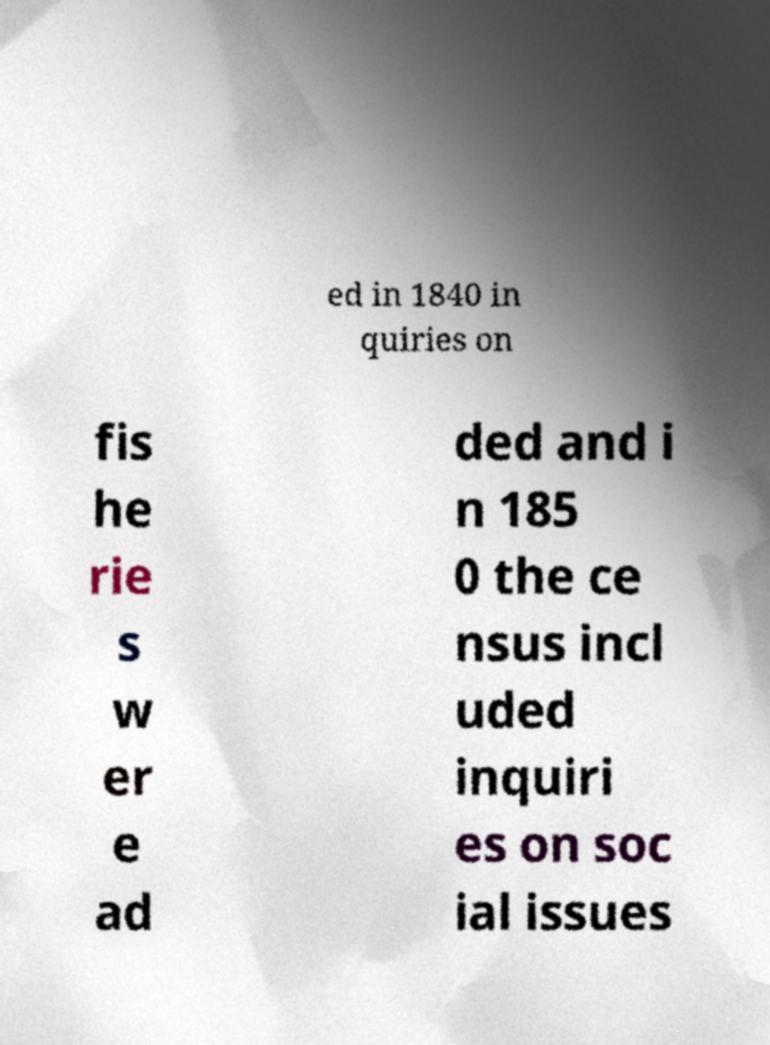Can you read and provide the text displayed in the image?This photo seems to have some interesting text. Can you extract and type it out for me? ed in 1840 in quiries on fis he rie s w er e ad ded and i n 185 0 the ce nsus incl uded inquiri es on soc ial issues 